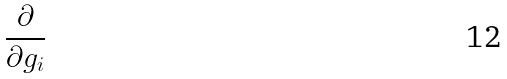Convert formula to latex. <formula><loc_0><loc_0><loc_500><loc_500>\frac { \partial } { \partial g _ { i } }</formula> 